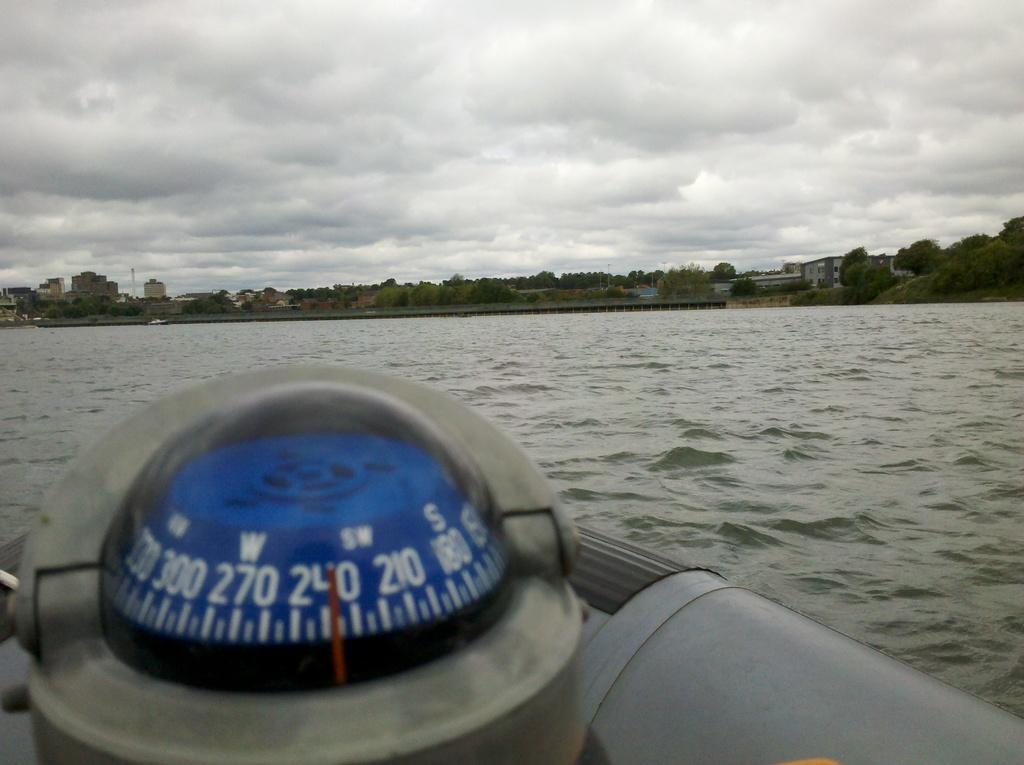What object is located in the foreground of the image? There is a compass in the foreground of the image. What can be seen in the middle of the image? There is water in the middle of the image. How would you describe the background of the image? The background of the image is cloudy. Where is the faucet located in the image? There is no faucet present in the image. What type of joke is being told by the compass in the image? There is no joke being told by the compass in the image, as it is an inanimate object. 